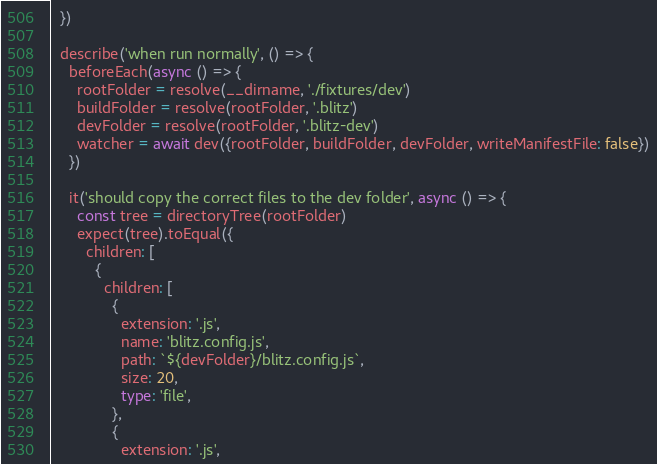<code> <loc_0><loc_0><loc_500><loc_500><_TypeScript_>  })

  describe('when run normally', () => {
    beforeEach(async () => {
      rootFolder = resolve(__dirname, './fixtures/dev')
      buildFolder = resolve(rootFolder, '.blitz')
      devFolder = resolve(rootFolder, '.blitz-dev')
      watcher = await dev({rootFolder, buildFolder, devFolder, writeManifestFile: false})
    })

    it('should copy the correct files to the dev folder', async () => {
      const tree = directoryTree(rootFolder)
      expect(tree).toEqual({
        children: [
          {
            children: [
              {
                extension: '.js',
                name: 'blitz.config.js',
                path: `${devFolder}/blitz.config.js`,
                size: 20,
                type: 'file',
              },
              {
                extension: '.js',</code> 